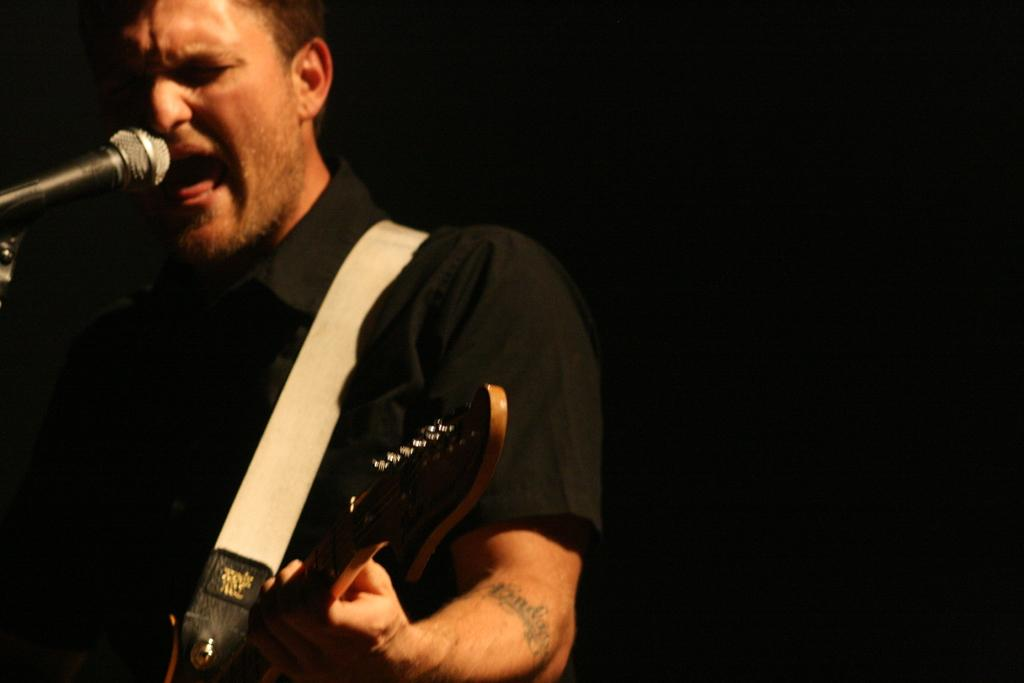Who is the main subject in the image? There is a man in the image. What is the man doing in the image? The man is singing and playing the guitar. Where is the man positioned in the image? The man is standing in the front. What can be observed about the background of the image? The background of the image is dark. What type of lamp is visible on the stage in the image? There is no lamp visible in the image; it only features a man singing and playing the guitar. What is the man using to hammer nails in the image? There is no hammer present in the image, nor is the man performing any activity that would require a hammer. 